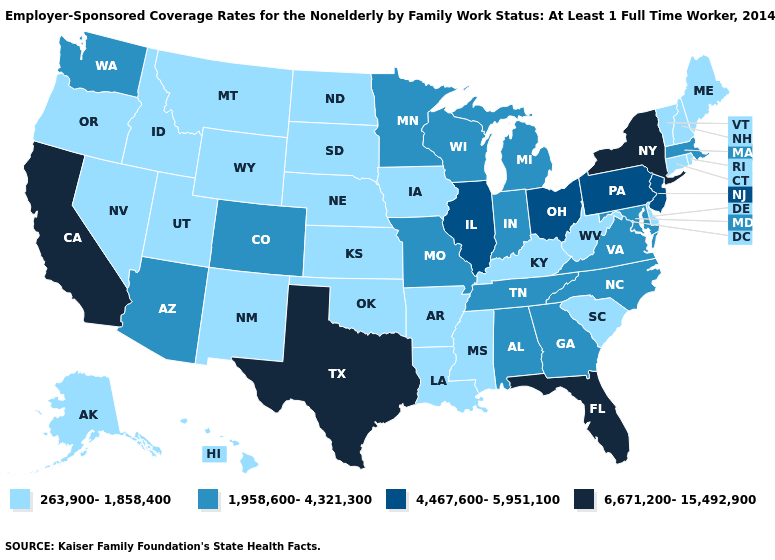What is the highest value in the Northeast ?
Concise answer only. 6,671,200-15,492,900. Among the states that border Colorado , does Wyoming have the highest value?
Concise answer only. No. Does Wyoming have the highest value in the USA?
Keep it brief. No. Name the states that have a value in the range 4,467,600-5,951,100?
Answer briefly. Illinois, New Jersey, Ohio, Pennsylvania. Among the states that border Mississippi , which have the lowest value?
Answer briefly. Arkansas, Louisiana. Does Minnesota have the same value as Maryland?
Quick response, please. Yes. What is the highest value in the USA?
Concise answer only. 6,671,200-15,492,900. Name the states that have a value in the range 263,900-1,858,400?
Keep it brief. Alaska, Arkansas, Connecticut, Delaware, Hawaii, Idaho, Iowa, Kansas, Kentucky, Louisiana, Maine, Mississippi, Montana, Nebraska, Nevada, New Hampshire, New Mexico, North Dakota, Oklahoma, Oregon, Rhode Island, South Carolina, South Dakota, Utah, Vermont, West Virginia, Wyoming. Which states hav the highest value in the MidWest?
Give a very brief answer. Illinois, Ohio. Which states have the lowest value in the South?
Be succinct. Arkansas, Delaware, Kentucky, Louisiana, Mississippi, Oklahoma, South Carolina, West Virginia. Which states have the lowest value in the MidWest?
Short answer required. Iowa, Kansas, Nebraska, North Dakota, South Dakota. Does Connecticut have the highest value in the USA?
Write a very short answer. No. Which states have the highest value in the USA?
Quick response, please. California, Florida, New York, Texas. What is the value of Vermont?
Quick response, please. 263,900-1,858,400. Name the states that have a value in the range 1,958,600-4,321,300?
Answer briefly. Alabama, Arizona, Colorado, Georgia, Indiana, Maryland, Massachusetts, Michigan, Minnesota, Missouri, North Carolina, Tennessee, Virginia, Washington, Wisconsin. 